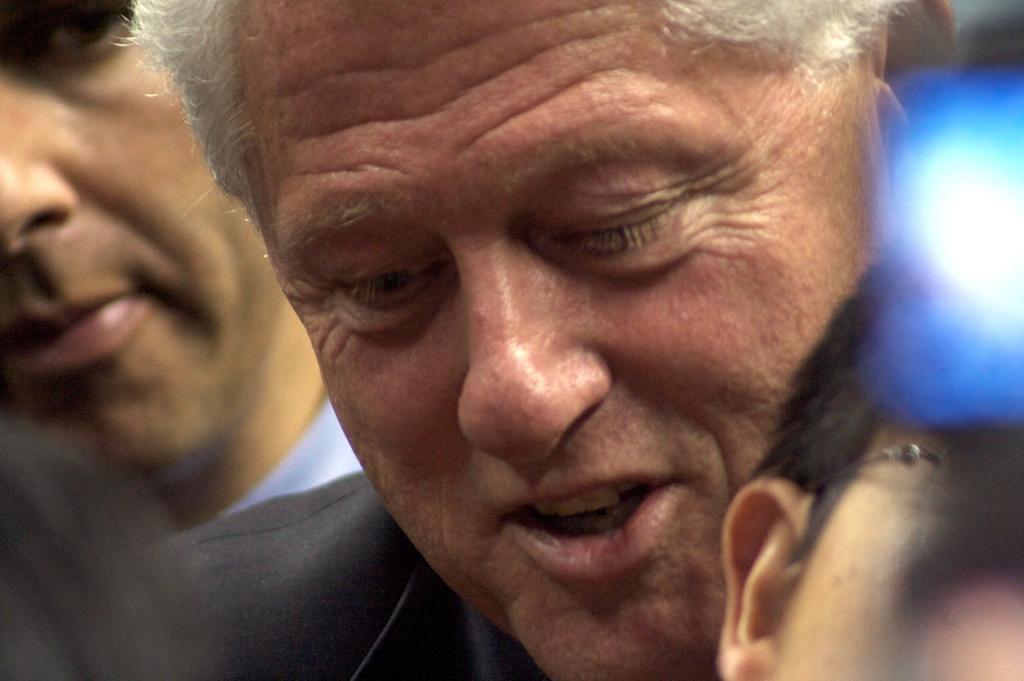Please provide a concise description of this image. In this image we can see few persons and on the right side we can see an object which looks like a light. 